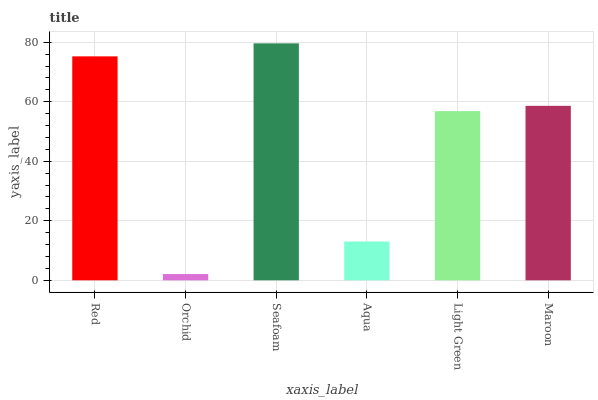Is Orchid the minimum?
Answer yes or no. Yes. Is Seafoam the maximum?
Answer yes or no. Yes. Is Seafoam the minimum?
Answer yes or no. No. Is Orchid the maximum?
Answer yes or no. No. Is Seafoam greater than Orchid?
Answer yes or no. Yes. Is Orchid less than Seafoam?
Answer yes or no. Yes. Is Orchid greater than Seafoam?
Answer yes or no. No. Is Seafoam less than Orchid?
Answer yes or no. No. Is Maroon the high median?
Answer yes or no. Yes. Is Light Green the low median?
Answer yes or no. Yes. Is Light Green the high median?
Answer yes or no. No. Is Orchid the low median?
Answer yes or no. No. 